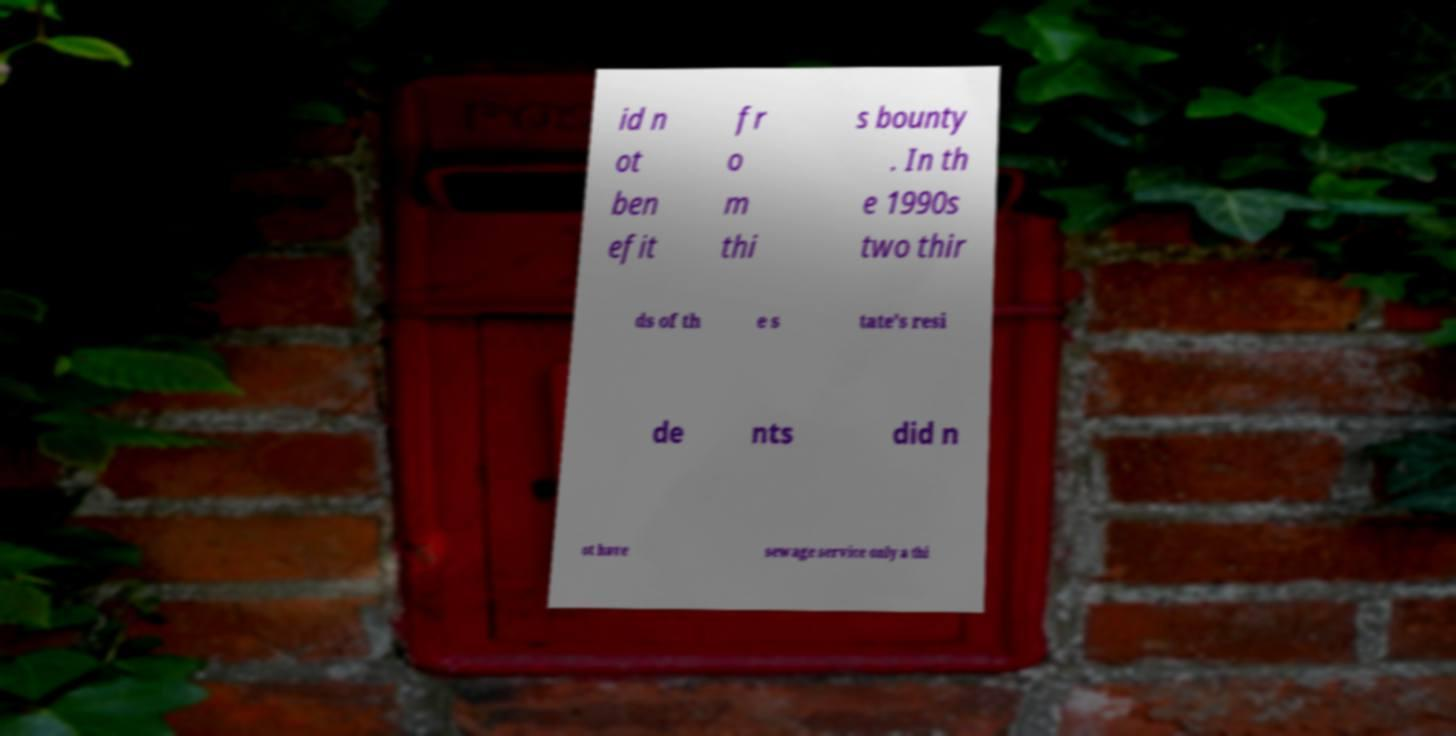Please read and relay the text visible in this image. What does it say? id n ot ben efit fr o m thi s bounty . In th e 1990s two thir ds of th e s tate's resi de nts did n ot have sewage service only a thi 